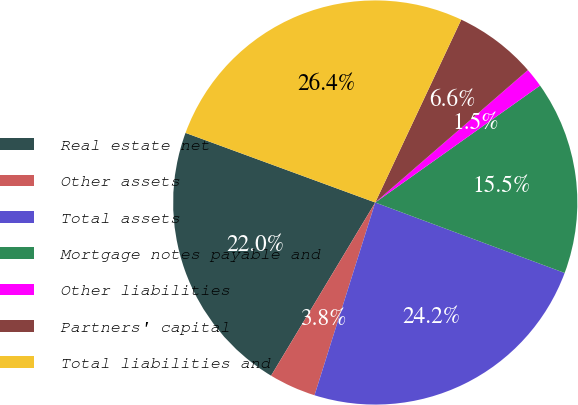Convert chart to OTSL. <chart><loc_0><loc_0><loc_500><loc_500><pie_chart><fcel>Real estate net<fcel>Other assets<fcel>Total assets<fcel>Mortgage notes payable and<fcel>Other liabilities<fcel>Partners' capital<fcel>Total liabilities and<nl><fcel>21.98%<fcel>3.76%<fcel>24.19%<fcel>15.49%<fcel>1.55%<fcel>6.63%<fcel>26.4%<nl></chart> 